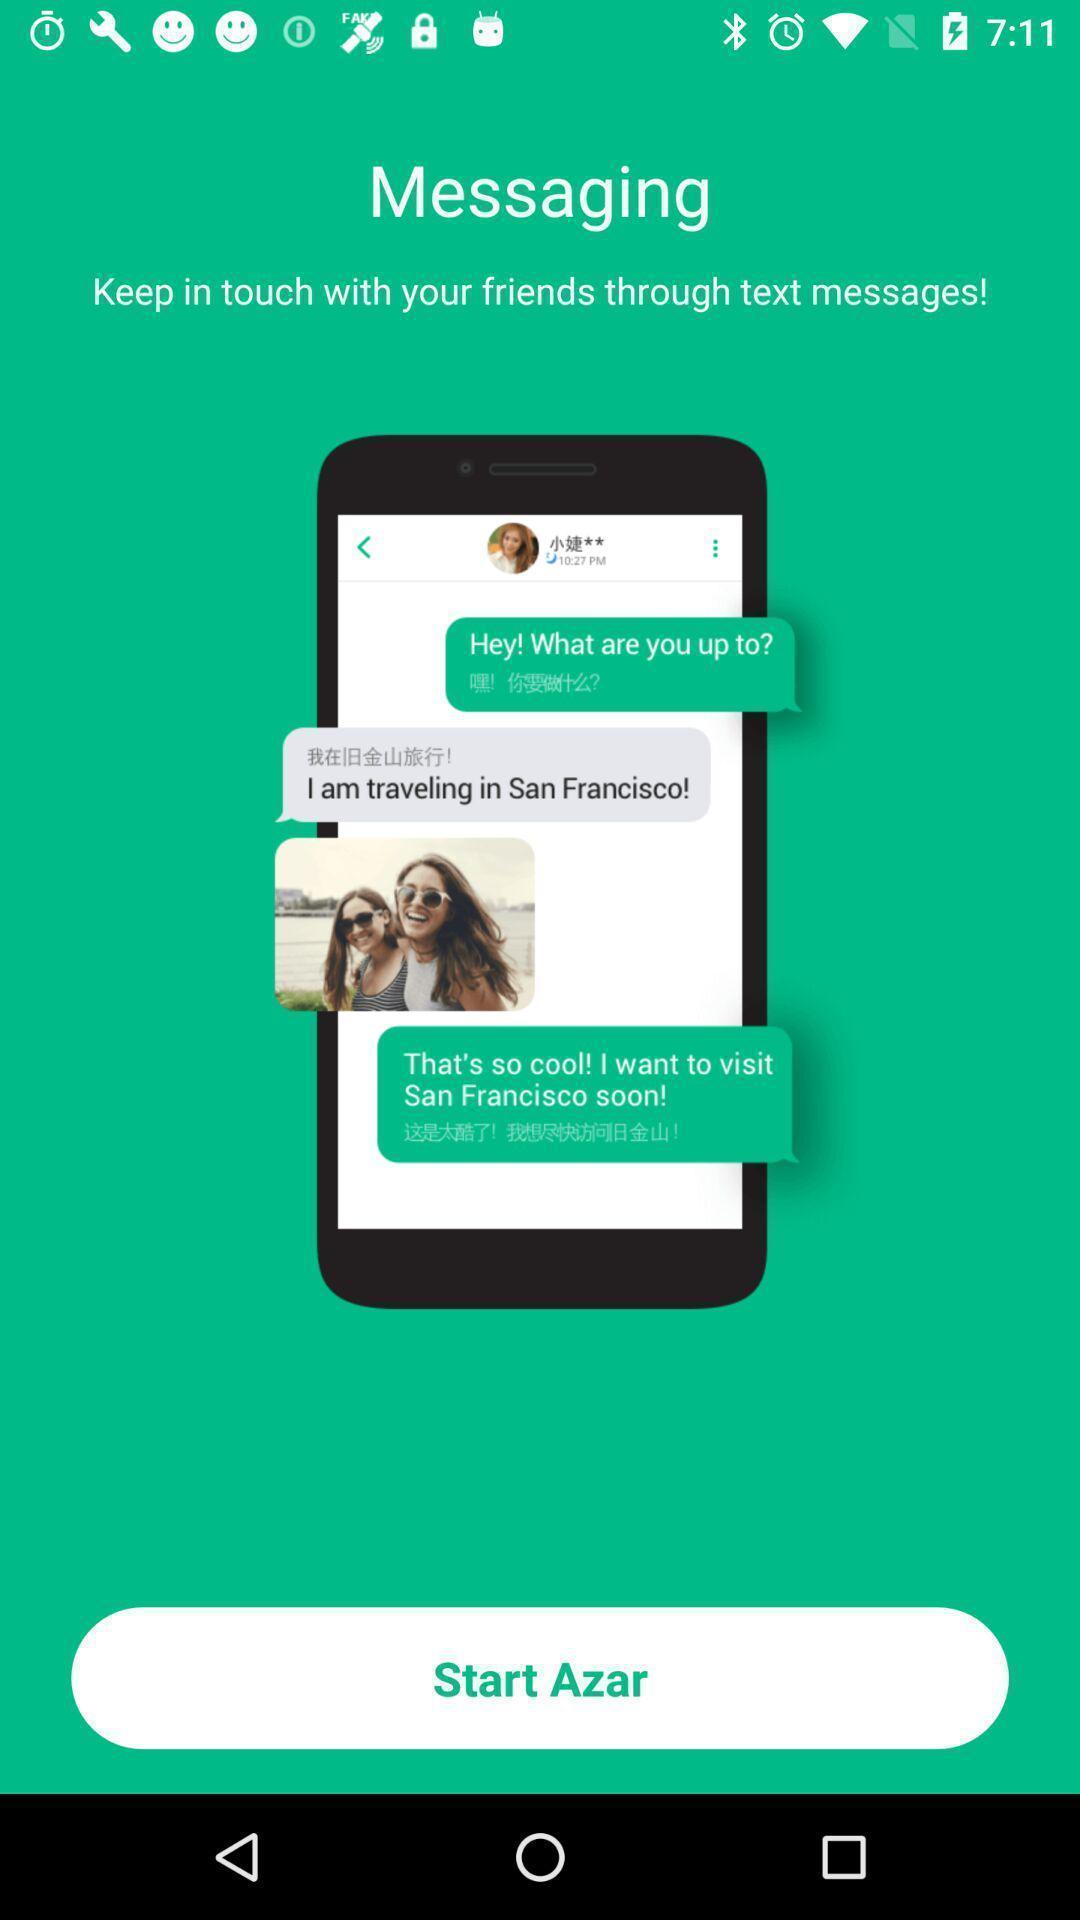What can you discern from this picture? Welcome page of a social app. 